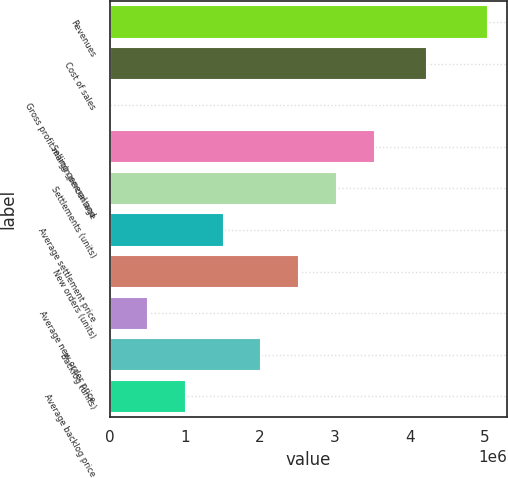<chart> <loc_0><loc_0><loc_500><loc_500><bar_chart><fcel>Revenues<fcel>Cost of sales<fcel>Gross profit margin percentage<fcel>Selling general and<fcel>Settlements (units)<fcel>Average settlement price<fcel>New orders (units)<fcel>Average new order price<fcel>Backlog (units)<fcel>Average backlog price<nl><fcel>5.04819e+06<fcel>4.22706e+06<fcel>16.3<fcel>3.53374e+06<fcel>3.02892e+06<fcel>1.51447e+06<fcel>2.5241e+06<fcel>504833<fcel>2.01928e+06<fcel>1.00965e+06<nl></chart> 